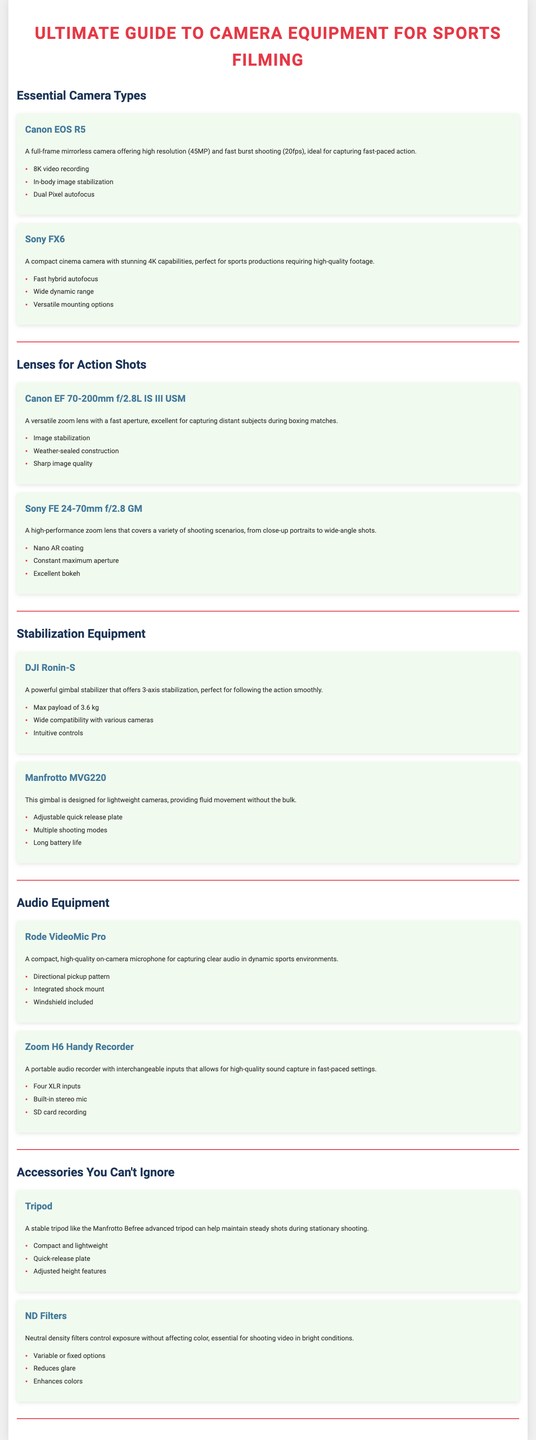What is the resolution of the Canon EOS R5? The Canon EOS R5 has a high resolution of 45MP.
Answer: 45MP What type of audio equipment is the Rode VideoMic Pro? The Rode VideoMic Pro is a compact, high-quality on-camera microphone.
Answer: On-camera microphone What is the maximum payload of the DJI Ronin-S? The DJI Ronin-S has a max payload of 3.6 kg.
Answer: 3.6 kg Which lens is recommended for capturing distant subjects during boxing matches? The Canon EF 70-200mm f/2.8L IS III USM is recommended for capturing distant subjects.
Answer: Canon EF 70-200mm f/2.8L IS III USM What is the main function of ND filters? ND filters control exposure without affecting color.
Answer: Control exposure What camera is highlighted for its 4K capabilities? The Sony FX6 is highlighted for its stunning 4K capabilities.
Answer: Sony FX6 What feature does the Manfrotto Befree advanced tripod offer? The Manfrotto Befree advanced tripod offers adjusted height features.
Answer: Adjusted height features Which microphone includes a windshield? The Rode VideoMic Pro includes a windshield.
Answer: Rode VideoMic Pro What is the aperture of the Sony FE 24-70mm lens? The Sony FE 24-70mm lens has a constant maximum aperture of f/2.8.
Answer: f/2.8 